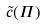Convert formula to latex. <formula><loc_0><loc_0><loc_500><loc_500>\tilde { c } ( \Pi )</formula> 